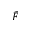<formula> <loc_0><loc_0><loc_500><loc_500>\tilde { F }</formula> 